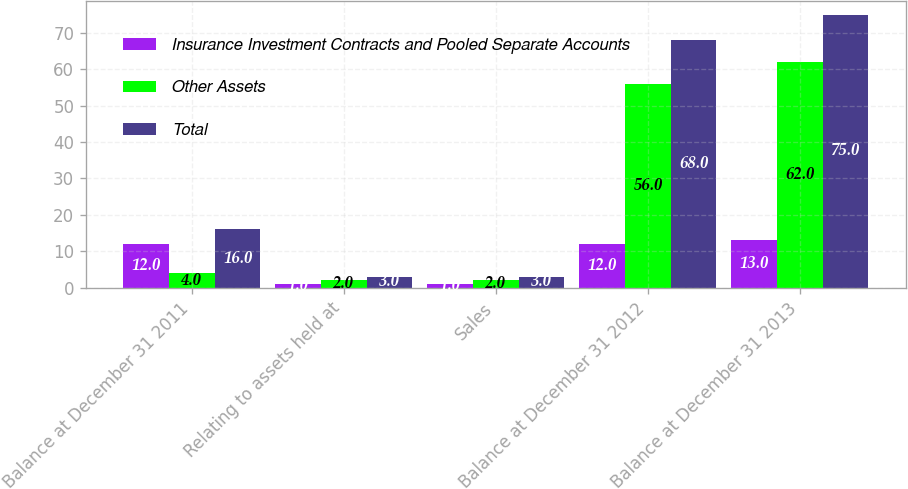Convert chart. <chart><loc_0><loc_0><loc_500><loc_500><stacked_bar_chart><ecel><fcel>Balance at December 31 2011<fcel>Relating to assets held at<fcel>Sales<fcel>Balance at December 31 2012<fcel>Balance at December 31 2013<nl><fcel>Insurance Investment Contracts and Pooled Separate Accounts<fcel>12<fcel>1<fcel>1<fcel>12<fcel>13<nl><fcel>Other Assets<fcel>4<fcel>2<fcel>2<fcel>56<fcel>62<nl><fcel>Total<fcel>16<fcel>3<fcel>3<fcel>68<fcel>75<nl></chart> 